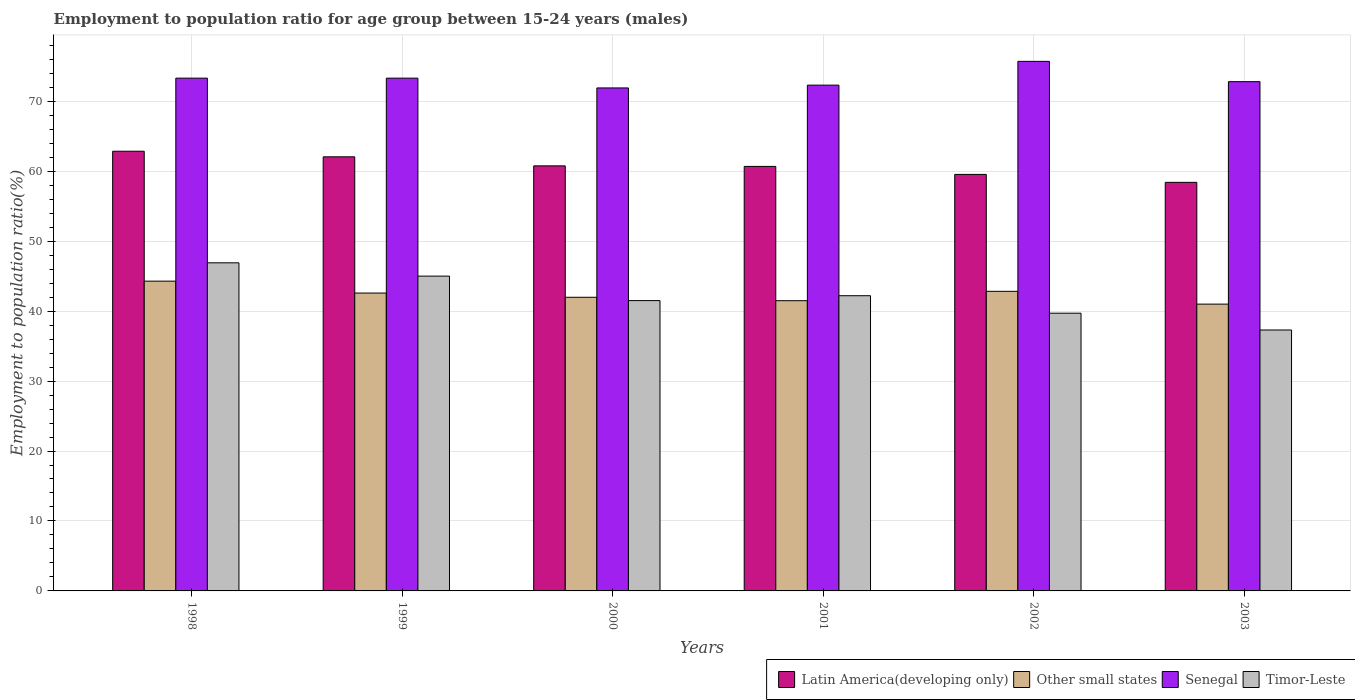How many different coloured bars are there?
Your response must be concise. 4. How many groups of bars are there?
Your answer should be very brief. 6. Are the number of bars per tick equal to the number of legend labels?
Your answer should be very brief. Yes. How many bars are there on the 6th tick from the right?
Your response must be concise. 4. In how many cases, is the number of bars for a given year not equal to the number of legend labels?
Your response must be concise. 0. What is the employment to population ratio in Senegal in 2003?
Your answer should be very brief. 72.8. Across all years, what is the maximum employment to population ratio in Timor-Leste?
Make the answer very short. 46.9. Across all years, what is the minimum employment to population ratio in Senegal?
Your response must be concise. 71.9. In which year was the employment to population ratio in Latin America(developing only) minimum?
Provide a succinct answer. 2003. What is the total employment to population ratio in Other small states in the graph?
Offer a very short reply. 254.15. What is the difference between the employment to population ratio in Latin America(developing only) in 2000 and that in 2002?
Provide a succinct answer. 1.22. What is the difference between the employment to population ratio in Latin America(developing only) in 2003 and the employment to population ratio in Senegal in 1998?
Make the answer very short. -14.9. What is the average employment to population ratio in Other small states per year?
Your answer should be very brief. 42.36. In the year 1998, what is the difference between the employment to population ratio in Other small states and employment to population ratio in Timor-Leste?
Make the answer very short. -2.62. What is the ratio of the employment to population ratio in Latin America(developing only) in 1998 to that in 2000?
Make the answer very short. 1.03. What is the difference between the highest and the second highest employment to population ratio in Timor-Leste?
Ensure brevity in your answer.  1.9. What is the difference between the highest and the lowest employment to population ratio in Senegal?
Provide a succinct answer. 3.8. In how many years, is the employment to population ratio in Senegal greater than the average employment to population ratio in Senegal taken over all years?
Keep it short and to the point. 3. Is the sum of the employment to population ratio in Timor-Leste in 2000 and 2003 greater than the maximum employment to population ratio in Other small states across all years?
Provide a short and direct response. Yes. What does the 2nd bar from the left in 2002 represents?
Provide a succinct answer. Other small states. What does the 1st bar from the right in 2002 represents?
Make the answer very short. Timor-Leste. How many years are there in the graph?
Your response must be concise. 6. Does the graph contain any zero values?
Offer a very short reply. No. Does the graph contain grids?
Your answer should be compact. Yes. Where does the legend appear in the graph?
Give a very brief answer. Bottom right. What is the title of the graph?
Provide a succinct answer. Employment to population ratio for age group between 15-24 years (males). What is the label or title of the X-axis?
Your answer should be very brief. Years. What is the Employment to population ratio(%) of Latin America(developing only) in 1998?
Provide a succinct answer. 62.85. What is the Employment to population ratio(%) in Other small states in 1998?
Make the answer very short. 44.28. What is the Employment to population ratio(%) in Senegal in 1998?
Your answer should be compact. 73.3. What is the Employment to population ratio(%) of Timor-Leste in 1998?
Give a very brief answer. 46.9. What is the Employment to population ratio(%) in Latin America(developing only) in 1999?
Ensure brevity in your answer.  62.05. What is the Employment to population ratio(%) of Other small states in 1999?
Ensure brevity in your answer.  42.58. What is the Employment to population ratio(%) of Senegal in 1999?
Offer a very short reply. 73.3. What is the Employment to population ratio(%) in Latin America(developing only) in 2000?
Give a very brief answer. 60.76. What is the Employment to population ratio(%) of Other small states in 2000?
Make the answer very short. 41.98. What is the Employment to population ratio(%) of Senegal in 2000?
Your answer should be compact. 71.9. What is the Employment to population ratio(%) in Timor-Leste in 2000?
Your answer should be very brief. 41.5. What is the Employment to population ratio(%) in Latin America(developing only) in 2001?
Offer a very short reply. 60.68. What is the Employment to population ratio(%) in Other small states in 2001?
Your response must be concise. 41.49. What is the Employment to population ratio(%) in Senegal in 2001?
Offer a very short reply. 72.3. What is the Employment to population ratio(%) in Timor-Leste in 2001?
Provide a short and direct response. 42.2. What is the Employment to population ratio(%) of Latin America(developing only) in 2002?
Make the answer very short. 59.54. What is the Employment to population ratio(%) of Other small states in 2002?
Offer a very short reply. 42.83. What is the Employment to population ratio(%) of Senegal in 2002?
Your answer should be compact. 75.7. What is the Employment to population ratio(%) in Timor-Leste in 2002?
Provide a short and direct response. 39.7. What is the Employment to population ratio(%) in Latin America(developing only) in 2003?
Provide a short and direct response. 58.4. What is the Employment to population ratio(%) of Other small states in 2003?
Your answer should be compact. 41. What is the Employment to population ratio(%) of Senegal in 2003?
Provide a short and direct response. 72.8. What is the Employment to population ratio(%) of Timor-Leste in 2003?
Provide a short and direct response. 37.3. Across all years, what is the maximum Employment to population ratio(%) in Latin America(developing only)?
Offer a very short reply. 62.85. Across all years, what is the maximum Employment to population ratio(%) in Other small states?
Your answer should be very brief. 44.28. Across all years, what is the maximum Employment to population ratio(%) of Senegal?
Provide a succinct answer. 75.7. Across all years, what is the maximum Employment to population ratio(%) of Timor-Leste?
Make the answer very short. 46.9. Across all years, what is the minimum Employment to population ratio(%) of Latin America(developing only)?
Provide a short and direct response. 58.4. Across all years, what is the minimum Employment to population ratio(%) in Other small states?
Offer a terse response. 41. Across all years, what is the minimum Employment to population ratio(%) in Senegal?
Offer a terse response. 71.9. Across all years, what is the minimum Employment to population ratio(%) in Timor-Leste?
Give a very brief answer. 37.3. What is the total Employment to population ratio(%) of Latin America(developing only) in the graph?
Make the answer very short. 364.3. What is the total Employment to population ratio(%) in Other small states in the graph?
Your answer should be compact. 254.15. What is the total Employment to population ratio(%) in Senegal in the graph?
Ensure brevity in your answer.  439.3. What is the total Employment to population ratio(%) in Timor-Leste in the graph?
Make the answer very short. 252.6. What is the difference between the Employment to population ratio(%) of Latin America(developing only) in 1998 and that in 1999?
Keep it short and to the point. 0.8. What is the difference between the Employment to population ratio(%) in Other small states in 1998 and that in 1999?
Provide a succinct answer. 1.7. What is the difference between the Employment to population ratio(%) in Timor-Leste in 1998 and that in 1999?
Your answer should be compact. 1.9. What is the difference between the Employment to population ratio(%) of Latin America(developing only) in 1998 and that in 2000?
Give a very brief answer. 2.09. What is the difference between the Employment to population ratio(%) in Other small states in 1998 and that in 2000?
Your answer should be compact. 2.3. What is the difference between the Employment to population ratio(%) in Timor-Leste in 1998 and that in 2000?
Ensure brevity in your answer.  5.4. What is the difference between the Employment to population ratio(%) of Latin America(developing only) in 1998 and that in 2001?
Provide a succinct answer. 2.17. What is the difference between the Employment to population ratio(%) of Other small states in 1998 and that in 2001?
Give a very brief answer. 2.79. What is the difference between the Employment to population ratio(%) in Latin America(developing only) in 1998 and that in 2002?
Make the answer very short. 3.31. What is the difference between the Employment to population ratio(%) of Other small states in 1998 and that in 2002?
Make the answer very short. 1.45. What is the difference between the Employment to population ratio(%) in Senegal in 1998 and that in 2002?
Provide a succinct answer. -2.4. What is the difference between the Employment to population ratio(%) of Latin America(developing only) in 1998 and that in 2003?
Your response must be concise. 4.45. What is the difference between the Employment to population ratio(%) in Other small states in 1998 and that in 2003?
Give a very brief answer. 3.28. What is the difference between the Employment to population ratio(%) in Senegal in 1998 and that in 2003?
Offer a terse response. 0.5. What is the difference between the Employment to population ratio(%) of Timor-Leste in 1998 and that in 2003?
Keep it short and to the point. 9.6. What is the difference between the Employment to population ratio(%) in Latin America(developing only) in 1999 and that in 2000?
Ensure brevity in your answer.  1.29. What is the difference between the Employment to population ratio(%) of Other small states in 1999 and that in 2000?
Offer a terse response. 0.6. What is the difference between the Employment to population ratio(%) of Timor-Leste in 1999 and that in 2000?
Ensure brevity in your answer.  3.5. What is the difference between the Employment to population ratio(%) of Latin America(developing only) in 1999 and that in 2001?
Offer a very short reply. 1.37. What is the difference between the Employment to population ratio(%) in Other small states in 1999 and that in 2001?
Offer a terse response. 1.09. What is the difference between the Employment to population ratio(%) in Senegal in 1999 and that in 2001?
Keep it short and to the point. 1. What is the difference between the Employment to population ratio(%) of Timor-Leste in 1999 and that in 2001?
Ensure brevity in your answer.  2.8. What is the difference between the Employment to population ratio(%) in Latin America(developing only) in 1999 and that in 2002?
Give a very brief answer. 2.51. What is the difference between the Employment to population ratio(%) of Other small states in 1999 and that in 2002?
Offer a very short reply. -0.25. What is the difference between the Employment to population ratio(%) of Senegal in 1999 and that in 2002?
Offer a terse response. -2.4. What is the difference between the Employment to population ratio(%) of Timor-Leste in 1999 and that in 2002?
Provide a short and direct response. 5.3. What is the difference between the Employment to population ratio(%) of Latin America(developing only) in 1999 and that in 2003?
Your response must be concise. 3.65. What is the difference between the Employment to population ratio(%) in Other small states in 1999 and that in 2003?
Provide a short and direct response. 1.58. What is the difference between the Employment to population ratio(%) of Senegal in 1999 and that in 2003?
Your answer should be compact. 0.5. What is the difference between the Employment to population ratio(%) of Latin America(developing only) in 2000 and that in 2001?
Your answer should be very brief. 0.08. What is the difference between the Employment to population ratio(%) of Other small states in 2000 and that in 2001?
Provide a short and direct response. 0.49. What is the difference between the Employment to population ratio(%) in Senegal in 2000 and that in 2001?
Ensure brevity in your answer.  -0.4. What is the difference between the Employment to population ratio(%) of Latin America(developing only) in 2000 and that in 2002?
Your response must be concise. 1.22. What is the difference between the Employment to population ratio(%) in Other small states in 2000 and that in 2002?
Your response must be concise. -0.85. What is the difference between the Employment to population ratio(%) in Senegal in 2000 and that in 2002?
Offer a very short reply. -3.8. What is the difference between the Employment to population ratio(%) of Latin America(developing only) in 2000 and that in 2003?
Make the answer very short. 2.36. What is the difference between the Employment to population ratio(%) in Other small states in 2000 and that in 2003?
Offer a very short reply. 0.98. What is the difference between the Employment to population ratio(%) of Senegal in 2000 and that in 2003?
Your answer should be very brief. -0.9. What is the difference between the Employment to population ratio(%) of Latin America(developing only) in 2001 and that in 2002?
Provide a short and direct response. 1.14. What is the difference between the Employment to population ratio(%) of Other small states in 2001 and that in 2002?
Provide a succinct answer. -1.34. What is the difference between the Employment to population ratio(%) of Timor-Leste in 2001 and that in 2002?
Ensure brevity in your answer.  2.5. What is the difference between the Employment to population ratio(%) in Latin America(developing only) in 2001 and that in 2003?
Offer a very short reply. 2.28. What is the difference between the Employment to population ratio(%) in Other small states in 2001 and that in 2003?
Your answer should be compact. 0.49. What is the difference between the Employment to population ratio(%) of Timor-Leste in 2001 and that in 2003?
Provide a short and direct response. 4.9. What is the difference between the Employment to population ratio(%) in Latin America(developing only) in 2002 and that in 2003?
Offer a very short reply. 1.14. What is the difference between the Employment to population ratio(%) of Other small states in 2002 and that in 2003?
Ensure brevity in your answer.  1.83. What is the difference between the Employment to population ratio(%) of Timor-Leste in 2002 and that in 2003?
Provide a short and direct response. 2.4. What is the difference between the Employment to population ratio(%) in Latin America(developing only) in 1998 and the Employment to population ratio(%) in Other small states in 1999?
Ensure brevity in your answer.  20.28. What is the difference between the Employment to population ratio(%) of Latin America(developing only) in 1998 and the Employment to population ratio(%) of Senegal in 1999?
Keep it short and to the point. -10.45. What is the difference between the Employment to population ratio(%) in Latin America(developing only) in 1998 and the Employment to population ratio(%) in Timor-Leste in 1999?
Your response must be concise. 17.85. What is the difference between the Employment to population ratio(%) in Other small states in 1998 and the Employment to population ratio(%) in Senegal in 1999?
Provide a succinct answer. -29.02. What is the difference between the Employment to population ratio(%) of Other small states in 1998 and the Employment to population ratio(%) of Timor-Leste in 1999?
Provide a succinct answer. -0.72. What is the difference between the Employment to population ratio(%) in Senegal in 1998 and the Employment to population ratio(%) in Timor-Leste in 1999?
Make the answer very short. 28.3. What is the difference between the Employment to population ratio(%) of Latin America(developing only) in 1998 and the Employment to population ratio(%) of Other small states in 2000?
Offer a terse response. 20.88. What is the difference between the Employment to population ratio(%) in Latin America(developing only) in 1998 and the Employment to population ratio(%) in Senegal in 2000?
Ensure brevity in your answer.  -9.05. What is the difference between the Employment to population ratio(%) in Latin America(developing only) in 1998 and the Employment to population ratio(%) in Timor-Leste in 2000?
Provide a succinct answer. 21.35. What is the difference between the Employment to population ratio(%) in Other small states in 1998 and the Employment to population ratio(%) in Senegal in 2000?
Your response must be concise. -27.62. What is the difference between the Employment to population ratio(%) in Other small states in 1998 and the Employment to population ratio(%) in Timor-Leste in 2000?
Your response must be concise. 2.78. What is the difference between the Employment to population ratio(%) of Senegal in 1998 and the Employment to population ratio(%) of Timor-Leste in 2000?
Make the answer very short. 31.8. What is the difference between the Employment to population ratio(%) in Latin America(developing only) in 1998 and the Employment to population ratio(%) in Other small states in 2001?
Your answer should be very brief. 21.37. What is the difference between the Employment to population ratio(%) of Latin America(developing only) in 1998 and the Employment to population ratio(%) of Senegal in 2001?
Provide a succinct answer. -9.45. What is the difference between the Employment to population ratio(%) in Latin America(developing only) in 1998 and the Employment to population ratio(%) in Timor-Leste in 2001?
Give a very brief answer. 20.65. What is the difference between the Employment to population ratio(%) in Other small states in 1998 and the Employment to population ratio(%) in Senegal in 2001?
Provide a short and direct response. -28.02. What is the difference between the Employment to population ratio(%) in Other small states in 1998 and the Employment to population ratio(%) in Timor-Leste in 2001?
Provide a succinct answer. 2.08. What is the difference between the Employment to population ratio(%) in Senegal in 1998 and the Employment to population ratio(%) in Timor-Leste in 2001?
Your answer should be compact. 31.1. What is the difference between the Employment to population ratio(%) in Latin America(developing only) in 1998 and the Employment to population ratio(%) in Other small states in 2002?
Offer a very short reply. 20.03. What is the difference between the Employment to population ratio(%) in Latin America(developing only) in 1998 and the Employment to population ratio(%) in Senegal in 2002?
Ensure brevity in your answer.  -12.85. What is the difference between the Employment to population ratio(%) in Latin America(developing only) in 1998 and the Employment to population ratio(%) in Timor-Leste in 2002?
Your response must be concise. 23.15. What is the difference between the Employment to population ratio(%) in Other small states in 1998 and the Employment to population ratio(%) in Senegal in 2002?
Keep it short and to the point. -31.42. What is the difference between the Employment to population ratio(%) of Other small states in 1998 and the Employment to population ratio(%) of Timor-Leste in 2002?
Offer a terse response. 4.58. What is the difference between the Employment to population ratio(%) of Senegal in 1998 and the Employment to population ratio(%) of Timor-Leste in 2002?
Give a very brief answer. 33.6. What is the difference between the Employment to population ratio(%) of Latin America(developing only) in 1998 and the Employment to population ratio(%) of Other small states in 2003?
Provide a succinct answer. 21.86. What is the difference between the Employment to population ratio(%) of Latin America(developing only) in 1998 and the Employment to population ratio(%) of Senegal in 2003?
Your answer should be compact. -9.95. What is the difference between the Employment to population ratio(%) of Latin America(developing only) in 1998 and the Employment to population ratio(%) of Timor-Leste in 2003?
Provide a succinct answer. 25.55. What is the difference between the Employment to population ratio(%) in Other small states in 1998 and the Employment to population ratio(%) in Senegal in 2003?
Provide a succinct answer. -28.52. What is the difference between the Employment to population ratio(%) in Other small states in 1998 and the Employment to population ratio(%) in Timor-Leste in 2003?
Offer a terse response. 6.98. What is the difference between the Employment to population ratio(%) in Senegal in 1998 and the Employment to population ratio(%) in Timor-Leste in 2003?
Offer a very short reply. 36. What is the difference between the Employment to population ratio(%) of Latin America(developing only) in 1999 and the Employment to population ratio(%) of Other small states in 2000?
Provide a succinct answer. 20.08. What is the difference between the Employment to population ratio(%) of Latin America(developing only) in 1999 and the Employment to population ratio(%) of Senegal in 2000?
Make the answer very short. -9.85. What is the difference between the Employment to population ratio(%) of Latin America(developing only) in 1999 and the Employment to population ratio(%) of Timor-Leste in 2000?
Give a very brief answer. 20.55. What is the difference between the Employment to population ratio(%) in Other small states in 1999 and the Employment to population ratio(%) in Senegal in 2000?
Give a very brief answer. -29.32. What is the difference between the Employment to population ratio(%) in Other small states in 1999 and the Employment to population ratio(%) in Timor-Leste in 2000?
Provide a short and direct response. 1.08. What is the difference between the Employment to population ratio(%) of Senegal in 1999 and the Employment to population ratio(%) of Timor-Leste in 2000?
Ensure brevity in your answer.  31.8. What is the difference between the Employment to population ratio(%) in Latin America(developing only) in 1999 and the Employment to population ratio(%) in Other small states in 2001?
Your answer should be very brief. 20.57. What is the difference between the Employment to population ratio(%) of Latin America(developing only) in 1999 and the Employment to population ratio(%) of Senegal in 2001?
Provide a succinct answer. -10.25. What is the difference between the Employment to population ratio(%) in Latin America(developing only) in 1999 and the Employment to population ratio(%) in Timor-Leste in 2001?
Give a very brief answer. 19.85. What is the difference between the Employment to population ratio(%) of Other small states in 1999 and the Employment to population ratio(%) of Senegal in 2001?
Keep it short and to the point. -29.72. What is the difference between the Employment to population ratio(%) in Other small states in 1999 and the Employment to population ratio(%) in Timor-Leste in 2001?
Give a very brief answer. 0.38. What is the difference between the Employment to population ratio(%) in Senegal in 1999 and the Employment to population ratio(%) in Timor-Leste in 2001?
Offer a very short reply. 31.1. What is the difference between the Employment to population ratio(%) of Latin America(developing only) in 1999 and the Employment to population ratio(%) of Other small states in 2002?
Offer a very short reply. 19.23. What is the difference between the Employment to population ratio(%) of Latin America(developing only) in 1999 and the Employment to population ratio(%) of Senegal in 2002?
Offer a terse response. -13.65. What is the difference between the Employment to population ratio(%) of Latin America(developing only) in 1999 and the Employment to population ratio(%) of Timor-Leste in 2002?
Offer a terse response. 22.35. What is the difference between the Employment to population ratio(%) in Other small states in 1999 and the Employment to population ratio(%) in Senegal in 2002?
Give a very brief answer. -33.12. What is the difference between the Employment to population ratio(%) in Other small states in 1999 and the Employment to population ratio(%) in Timor-Leste in 2002?
Keep it short and to the point. 2.88. What is the difference between the Employment to population ratio(%) in Senegal in 1999 and the Employment to population ratio(%) in Timor-Leste in 2002?
Your answer should be compact. 33.6. What is the difference between the Employment to population ratio(%) of Latin America(developing only) in 1999 and the Employment to population ratio(%) of Other small states in 2003?
Make the answer very short. 21.05. What is the difference between the Employment to population ratio(%) in Latin America(developing only) in 1999 and the Employment to population ratio(%) in Senegal in 2003?
Make the answer very short. -10.75. What is the difference between the Employment to population ratio(%) of Latin America(developing only) in 1999 and the Employment to population ratio(%) of Timor-Leste in 2003?
Your answer should be very brief. 24.75. What is the difference between the Employment to population ratio(%) of Other small states in 1999 and the Employment to population ratio(%) of Senegal in 2003?
Your response must be concise. -30.22. What is the difference between the Employment to population ratio(%) of Other small states in 1999 and the Employment to population ratio(%) of Timor-Leste in 2003?
Your response must be concise. 5.28. What is the difference between the Employment to population ratio(%) of Senegal in 1999 and the Employment to population ratio(%) of Timor-Leste in 2003?
Offer a very short reply. 36. What is the difference between the Employment to population ratio(%) of Latin America(developing only) in 2000 and the Employment to population ratio(%) of Other small states in 2001?
Offer a terse response. 19.27. What is the difference between the Employment to population ratio(%) of Latin America(developing only) in 2000 and the Employment to population ratio(%) of Senegal in 2001?
Give a very brief answer. -11.54. What is the difference between the Employment to population ratio(%) in Latin America(developing only) in 2000 and the Employment to population ratio(%) in Timor-Leste in 2001?
Your response must be concise. 18.56. What is the difference between the Employment to population ratio(%) of Other small states in 2000 and the Employment to population ratio(%) of Senegal in 2001?
Your answer should be very brief. -30.32. What is the difference between the Employment to population ratio(%) in Other small states in 2000 and the Employment to population ratio(%) in Timor-Leste in 2001?
Provide a succinct answer. -0.22. What is the difference between the Employment to population ratio(%) of Senegal in 2000 and the Employment to population ratio(%) of Timor-Leste in 2001?
Make the answer very short. 29.7. What is the difference between the Employment to population ratio(%) in Latin America(developing only) in 2000 and the Employment to population ratio(%) in Other small states in 2002?
Make the answer very short. 17.93. What is the difference between the Employment to population ratio(%) in Latin America(developing only) in 2000 and the Employment to population ratio(%) in Senegal in 2002?
Make the answer very short. -14.94. What is the difference between the Employment to population ratio(%) of Latin America(developing only) in 2000 and the Employment to population ratio(%) of Timor-Leste in 2002?
Your response must be concise. 21.06. What is the difference between the Employment to population ratio(%) in Other small states in 2000 and the Employment to population ratio(%) in Senegal in 2002?
Offer a very short reply. -33.72. What is the difference between the Employment to population ratio(%) in Other small states in 2000 and the Employment to population ratio(%) in Timor-Leste in 2002?
Keep it short and to the point. 2.28. What is the difference between the Employment to population ratio(%) of Senegal in 2000 and the Employment to population ratio(%) of Timor-Leste in 2002?
Provide a succinct answer. 32.2. What is the difference between the Employment to population ratio(%) of Latin America(developing only) in 2000 and the Employment to population ratio(%) of Other small states in 2003?
Make the answer very short. 19.76. What is the difference between the Employment to population ratio(%) in Latin America(developing only) in 2000 and the Employment to population ratio(%) in Senegal in 2003?
Ensure brevity in your answer.  -12.04. What is the difference between the Employment to population ratio(%) of Latin America(developing only) in 2000 and the Employment to population ratio(%) of Timor-Leste in 2003?
Your answer should be very brief. 23.46. What is the difference between the Employment to population ratio(%) in Other small states in 2000 and the Employment to population ratio(%) in Senegal in 2003?
Offer a terse response. -30.82. What is the difference between the Employment to population ratio(%) of Other small states in 2000 and the Employment to population ratio(%) of Timor-Leste in 2003?
Your answer should be very brief. 4.68. What is the difference between the Employment to population ratio(%) in Senegal in 2000 and the Employment to population ratio(%) in Timor-Leste in 2003?
Your answer should be very brief. 34.6. What is the difference between the Employment to population ratio(%) of Latin America(developing only) in 2001 and the Employment to population ratio(%) of Other small states in 2002?
Provide a succinct answer. 17.86. What is the difference between the Employment to population ratio(%) in Latin America(developing only) in 2001 and the Employment to population ratio(%) in Senegal in 2002?
Your response must be concise. -15.02. What is the difference between the Employment to population ratio(%) of Latin America(developing only) in 2001 and the Employment to population ratio(%) of Timor-Leste in 2002?
Offer a very short reply. 20.98. What is the difference between the Employment to population ratio(%) in Other small states in 2001 and the Employment to population ratio(%) in Senegal in 2002?
Make the answer very short. -34.21. What is the difference between the Employment to population ratio(%) in Other small states in 2001 and the Employment to population ratio(%) in Timor-Leste in 2002?
Keep it short and to the point. 1.79. What is the difference between the Employment to population ratio(%) of Senegal in 2001 and the Employment to population ratio(%) of Timor-Leste in 2002?
Your answer should be very brief. 32.6. What is the difference between the Employment to population ratio(%) of Latin America(developing only) in 2001 and the Employment to population ratio(%) of Other small states in 2003?
Ensure brevity in your answer.  19.69. What is the difference between the Employment to population ratio(%) in Latin America(developing only) in 2001 and the Employment to population ratio(%) in Senegal in 2003?
Give a very brief answer. -12.12. What is the difference between the Employment to population ratio(%) in Latin America(developing only) in 2001 and the Employment to population ratio(%) in Timor-Leste in 2003?
Give a very brief answer. 23.38. What is the difference between the Employment to population ratio(%) in Other small states in 2001 and the Employment to population ratio(%) in Senegal in 2003?
Your response must be concise. -31.31. What is the difference between the Employment to population ratio(%) in Other small states in 2001 and the Employment to population ratio(%) in Timor-Leste in 2003?
Give a very brief answer. 4.19. What is the difference between the Employment to population ratio(%) in Senegal in 2001 and the Employment to population ratio(%) in Timor-Leste in 2003?
Ensure brevity in your answer.  35. What is the difference between the Employment to population ratio(%) of Latin America(developing only) in 2002 and the Employment to population ratio(%) of Other small states in 2003?
Provide a succinct answer. 18.54. What is the difference between the Employment to population ratio(%) of Latin America(developing only) in 2002 and the Employment to population ratio(%) of Senegal in 2003?
Provide a succinct answer. -13.26. What is the difference between the Employment to population ratio(%) in Latin America(developing only) in 2002 and the Employment to population ratio(%) in Timor-Leste in 2003?
Provide a short and direct response. 22.24. What is the difference between the Employment to population ratio(%) in Other small states in 2002 and the Employment to population ratio(%) in Senegal in 2003?
Provide a succinct answer. -29.97. What is the difference between the Employment to population ratio(%) in Other small states in 2002 and the Employment to population ratio(%) in Timor-Leste in 2003?
Provide a short and direct response. 5.53. What is the difference between the Employment to population ratio(%) of Senegal in 2002 and the Employment to population ratio(%) of Timor-Leste in 2003?
Provide a short and direct response. 38.4. What is the average Employment to population ratio(%) of Latin America(developing only) per year?
Provide a short and direct response. 60.72. What is the average Employment to population ratio(%) in Other small states per year?
Give a very brief answer. 42.36. What is the average Employment to population ratio(%) of Senegal per year?
Keep it short and to the point. 73.22. What is the average Employment to population ratio(%) in Timor-Leste per year?
Your answer should be compact. 42.1. In the year 1998, what is the difference between the Employment to population ratio(%) of Latin America(developing only) and Employment to population ratio(%) of Other small states?
Your answer should be compact. 18.57. In the year 1998, what is the difference between the Employment to population ratio(%) of Latin America(developing only) and Employment to population ratio(%) of Senegal?
Your response must be concise. -10.45. In the year 1998, what is the difference between the Employment to population ratio(%) of Latin America(developing only) and Employment to population ratio(%) of Timor-Leste?
Your answer should be very brief. 15.95. In the year 1998, what is the difference between the Employment to population ratio(%) in Other small states and Employment to population ratio(%) in Senegal?
Your answer should be very brief. -29.02. In the year 1998, what is the difference between the Employment to population ratio(%) of Other small states and Employment to population ratio(%) of Timor-Leste?
Provide a short and direct response. -2.62. In the year 1998, what is the difference between the Employment to population ratio(%) in Senegal and Employment to population ratio(%) in Timor-Leste?
Provide a short and direct response. 26.4. In the year 1999, what is the difference between the Employment to population ratio(%) of Latin America(developing only) and Employment to population ratio(%) of Other small states?
Your response must be concise. 19.47. In the year 1999, what is the difference between the Employment to population ratio(%) of Latin America(developing only) and Employment to population ratio(%) of Senegal?
Make the answer very short. -11.25. In the year 1999, what is the difference between the Employment to population ratio(%) in Latin America(developing only) and Employment to population ratio(%) in Timor-Leste?
Offer a very short reply. 17.05. In the year 1999, what is the difference between the Employment to population ratio(%) of Other small states and Employment to population ratio(%) of Senegal?
Your answer should be very brief. -30.72. In the year 1999, what is the difference between the Employment to population ratio(%) of Other small states and Employment to population ratio(%) of Timor-Leste?
Provide a succinct answer. -2.42. In the year 1999, what is the difference between the Employment to population ratio(%) in Senegal and Employment to population ratio(%) in Timor-Leste?
Ensure brevity in your answer.  28.3. In the year 2000, what is the difference between the Employment to population ratio(%) of Latin America(developing only) and Employment to population ratio(%) of Other small states?
Your answer should be compact. 18.78. In the year 2000, what is the difference between the Employment to population ratio(%) of Latin America(developing only) and Employment to population ratio(%) of Senegal?
Give a very brief answer. -11.14. In the year 2000, what is the difference between the Employment to population ratio(%) in Latin America(developing only) and Employment to population ratio(%) in Timor-Leste?
Your answer should be very brief. 19.26. In the year 2000, what is the difference between the Employment to population ratio(%) in Other small states and Employment to population ratio(%) in Senegal?
Offer a terse response. -29.92. In the year 2000, what is the difference between the Employment to population ratio(%) of Other small states and Employment to population ratio(%) of Timor-Leste?
Offer a very short reply. 0.48. In the year 2000, what is the difference between the Employment to population ratio(%) of Senegal and Employment to population ratio(%) of Timor-Leste?
Offer a very short reply. 30.4. In the year 2001, what is the difference between the Employment to population ratio(%) in Latin America(developing only) and Employment to population ratio(%) in Other small states?
Offer a very short reply. 19.2. In the year 2001, what is the difference between the Employment to population ratio(%) in Latin America(developing only) and Employment to population ratio(%) in Senegal?
Ensure brevity in your answer.  -11.62. In the year 2001, what is the difference between the Employment to population ratio(%) of Latin America(developing only) and Employment to population ratio(%) of Timor-Leste?
Provide a short and direct response. 18.48. In the year 2001, what is the difference between the Employment to population ratio(%) in Other small states and Employment to population ratio(%) in Senegal?
Offer a very short reply. -30.81. In the year 2001, what is the difference between the Employment to population ratio(%) in Other small states and Employment to population ratio(%) in Timor-Leste?
Offer a terse response. -0.71. In the year 2001, what is the difference between the Employment to population ratio(%) in Senegal and Employment to population ratio(%) in Timor-Leste?
Keep it short and to the point. 30.1. In the year 2002, what is the difference between the Employment to population ratio(%) in Latin America(developing only) and Employment to population ratio(%) in Other small states?
Your answer should be very brief. 16.71. In the year 2002, what is the difference between the Employment to population ratio(%) of Latin America(developing only) and Employment to population ratio(%) of Senegal?
Provide a short and direct response. -16.16. In the year 2002, what is the difference between the Employment to population ratio(%) in Latin America(developing only) and Employment to population ratio(%) in Timor-Leste?
Make the answer very short. 19.84. In the year 2002, what is the difference between the Employment to population ratio(%) in Other small states and Employment to population ratio(%) in Senegal?
Ensure brevity in your answer.  -32.87. In the year 2002, what is the difference between the Employment to population ratio(%) of Other small states and Employment to population ratio(%) of Timor-Leste?
Your response must be concise. 3.13. In the year 2003, what is the difference between the Employment to population ratio(%) of Latin America(developing only) and Employment to population ratio(%) of Other small states?
Your answer should be compact. 17.4. In the year 2003, what is the difference between the Employment to population ratio(%) in Latin America(developing only) and Employment to population ratio(%) in Senegal?
Offer a terse response. -14.4. In the year 2003, what is the difference between the Employment to population ratio(%) in Latin America(developing only) and Employment to population ratio(%) in Timor-Leste?
Provide a short and direct response. 21.1. In the year 2003, what is the difference between the Employment to population ratio(%) of Other small states and Employment to population ratio(%) of Senegal?
Your answer should be very brief. -31.8. In the year 2003, what is the difference between the Employment to population ratio(%) of Other small states and Employment to population ratio(%) of Timor-Leste?
Offer a very short reply. 3.7. In the year 2003, what is the difference between the Employment to population ratio(%) in Senegal and Employment to population ratio(%) in Timor-Leste?
Provide a short and direct response. 35.5. What is the ratio of the Employment to population ratio(%) in Latin America(developing only) in 1998 to that in 1999?
Ensure brevity in your answer.  1.01. What is the ratio of the Employment to population ratio(%) in Other small states in 1998 to that in 1999?
Provide a short and direct response. 1.04. What is the ratio of the Employment to population ratio(%) in Senegal in 1998 to that in 1999?
Ensure brevity in your answer.  1. What is the ratio of the Employment to population ratio(%) of Timor-Leste in 1998 to that in 1999?
Offer a very short reply. 1.04. What is the ratio of the Employment to population ratio(%) of Latin America(developing only) in 1998 to that in 2000?
Offer a very short reply. 1.03. What is the ratio of the Employment to population ratio(%) of Other small states in 1998 to that in 2000?
Your answer should be compact. 1.05. What is the ratio of the Employment to population ratio(%) in Senegal in 1998 to that in 2000?
Ensure brevity in your answer.  1.02. What is the ratio of the Employment to population ratio(%) in Timor-Leste in 1998 to that in 2000?
Your answer should be very brief. 1.13. What is the ratio of the Employment to population ratio(%) in Latin America(developing only) in 1998 to that in 2001?
Provide a succinct answer. 1.04. What is the ratio of the Employment to population ratio(%) of Other small states in 1998 to that in 2001?
Your response must be concise. 1.07. What is the ratio of the Employment to population ratio(%) of Senegal in 1998 to that in 2001?
Make the answer very short. 1.01. What is the ratio of the Employment to population ratio(%) of Timor-Leste in 1998 to that in 2001?
Offer a terse response. 1.11. What is the ratio of the Employment to population ratio(%) of Latin America(developing only) in 1998 to that in 2002?
Your answer should be compact. 1.06. What is the ratio of the Employment to population ratio(%) of Other small states in 1998 to that in 2002?
Give a very brief answer. 1.03. What is the ratio of the Employment to population ratio(%) in Senegal in 1998 to that in 2002?
Keep it short and to the point. 0.97. What is the ratio of the Employment to population ratio(%) of Timor-Leste in 1998 to that in 2002?
Give a very brief answer. 1.18. What is the ratio of the Employment to population ratio(%) of Latin America(developing only) in 1998 to that in 2003?
Your answer should be very brief. 1.08. What is the ratio of the Employment to population ratio(%) in Other small states in 1998 to that in 2003?
Your response must be concise. 1.08. What is the ratio of the Employment to population ratio(%) in Senegal in 1998 to that in 2003?
Offer a terse response. 1.01. What is the ratio of the Employment to population ratio(%) in Timor-Leste in 1998 to that in 2003?
Offer a terse response. 1.26. What is the ratio of the Employment to population ratio(%) of Latin America(developing only) in 1999 to that in 2000?
Offer a terse response. 1.02. What is the ratio of the Employment to population ratio(%) in Other small states in 1999 to that in 2000?
Your response must be concise. 1.01. What is the ratio of the Employment to population ratio(%) in Senegal in 1999 to that in 2000?
Ensure brevity in your answer.  1.02. What is the ratio of the Employment to population ratio(%) of Timor-Leste in 1999 to that in 2000?
Offer a terse response. 1.08. What is the ratio of the Employment to population ratio(%) of Latin America(developing only) in 1999 to that in 2001?
Ensure brevity in your answer.  1.02. What is the ratio of the Employment to population ratio(%) of Other small states in 1999 to that in 2001?
Your answer should be very brief. 1.03. What is the ratio of the Employment to population ratio(%) in Senegal in 1999 to that in 2001?
Offer a very short reply. 1.01. What is the ratio of the Employment to population ratio(%) in Timor-Leste in 1999 to that in 2001?
Offer a very short reply. 1.07. What is the ratio of the Employment to population ratio(%) of Latin America(developing only) in 1999 to that in 2002?
Your answer should be very brief. 1.04. What is the ratio of the Employment to population ratio(%) of Other small states in 1999 to that in 2002?
Your answer should be very brief. 0.99. What is the ratio of the Employment to population ratio(%) in Senegal in 1999 to that in 2002?
Provide a short and direct response. 0.97. What is the ratio of the Employment to population ratio(%) of Timor-Leste in 1999 to that in 2002?
Your response must be concise. 1.13. What is the ratio of the Employment to population ratio(%) in Senegal in 1999 to that in 2003?
Give a very brief answer. 1.01. What is the ratio of the Employment to population ratio(%) in Timor-Leste in 1999 to that in 2003?
Offer a very short reply. 1.21. What is the ratio of the Employment to population ratio(%) in Latin America(developing only) in 2000 to that in 2001?
Ensure brevity in your answer.  1. What is the ratio of the Employment to population ratio(%) of Other small states in 2000 to that in 2001?
Your answer should be very brief. 1.01. What is the ratio of the Employment to population ratio(%) in Timor-Leste in 2000 to that in 2001?
Provide a short and direct response. 0.98. What is the ratio of the Employment to population ratio(%) of Latin America(developing only) in 2000 to that in 2002?
Keep it short and to the point. 1.02. What is the ratio of the Employment to population ratio(%) in Other small states in 2000 to that in 2002?
Make the answer very short. 0.98. What is the ratio of the Employment to population ratio(%) of Senegal in 2000 to that in 2002?
Your answer should be very brief. 0.95. What is the ratio of the Employment to population ratio(%) of Timor-Leste in 2000 to that in 2002?
Your answer should be very brief. 1.05. What is the ratio of the Employment to population ratio(%) in Latin America(developing only) in 2000 to that in 2003?
Offer a very short reply. 1.04. What is the ratio of the Employment to population ratio(%) of Other small states in 2000 to that in 2003?
Ensure brevity in your answer.  1.02. What is the ratio of the Employment to population ratio(%) in Senegal in 2000 to that in 2003?
Make the answer very short. 0.99. What is the ratio of the Employment to population ratio(%) in Timor-Leste in 2000 to that in 2003?
Give a very brief answer. 1.11. What is the ratio of the Employment to population ratio(%) of Latin America(developing only) in 2001 to that in 2002?
Provide a short and direct response. 1.02. What is the ratio of the Employment to population ratio(%) in Other small states in 2001 to that in 2002?
Your response must be concise. 0.97. What is the ratio of the Employment to population ratio(%) in Senegal in 2001 to that in 2002?
Offer a very short reply. 0.96. What is the ratio of the Employment to population ratio(%) of Timor-Leste in 2001 to that in 2002?
Offer a very short reply. 1.06. What is the ratio of the Employment to population ratio(%) in Latin America(developing only) in 2001 to that in 2003?
Make the answer very short. 1.04. What is the ratio of the Employment to population ratio(%) in Other small states in 2001 to that in 2003?
Make the answer very short. 1.01. What is the ratio of the Employment to population ratio(%) of Senegal in 2001 to that in 2003?
Ensure brevity in your answer.  0.99. What is the ratio of the Employment to population ratio(%) in Timor-Leste in 2001 to that in 2003?
Keep it short and to the point. 1.13. What is the ratio of the Employment to population ratio(%) in Latin America(developing only) in 2002 to that in 2003?
Make the answer very short. 1.02. What is the ratio of the Employment to population ratio(%) of Other small states in 2002 to that in 2003?
Offer a terse response. 1.04. What is the ratio of the Employment to population ratio(%) in Senegal in 2002 to that in 2003?
Your answer should be very brief. 1.04. What is the ratio of the Employment to population ratio(%) of Timor-Leste in 2002 to that in 2003?
Make the answer very short. 1.06. What is the difference between the highest and the second highest Employment to population ratio(%) in Latin America(developing only)?
Your answer should be compact. 0.8. What is the difference between the highest and the second highest Employment to population ratio(%) in Other small states?
Ensure brevity in your answer.  1.45. What is the difference between the highest and the second highest Employment to population ratio(%) in Senegal?
Your answer should be very brief. 2.4. What is the difference between the highest and the second highest Employment to population ratio(%) of Timor-Leste?
Provide a succinct answer. 1.9. What is the difference between the highest and the lowest Employment to population ratio(%) in Latin America(developing only)?
Provide a short and direct response. 4.45. What is the difference between the highest and the lowest Employment to population ratio(%) of Other small states?
Keep it short and to the point. 3.28. What is the difference between the highest and the lowest Employment to population ratio(%) in Senegal?
Keep it short and to the point. 3.8. 